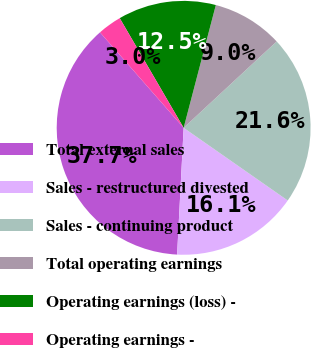<chart> <loc_0><loc_0><loc_500><loc_500><pie_chart><fcel>Total external sales<fcel>Sales - restructured divested<fcel>Sales - continuing product<fcel>Total operating earnings<fcel>Operating earnings (loss) -<fcel>Operating earnings -<nl><fcel>37.73%<fcel>16.12%<fcel>21.61%<fcel>9.01%<fcel>12.48%<fcel>3.05%<nl></chart> 